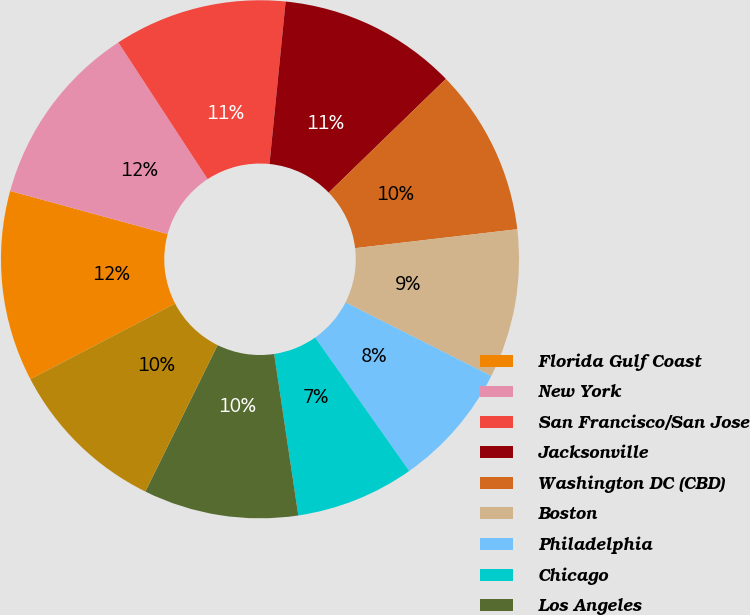Convert chart. <chart><loc_0><loc_0><loc_500><loc_500><pie_chart><fcel>Florida Gulf Coast<fcel>New York<fcel>San Francisco/San Jose<fcel>Jacksonville<fcel>Washington DC (CBD)<fcel>Boston<fcel>Philadelphia<fcel>Chicago<fcel>Los Angeles<fcel>Seattle<nl><fcel>11.91%<fcel>11.54%<fcel>10.79%<fcel>11.16%<fcel>10.41%<fcel>9.29%<fcel>7.79%<fcel>7.41%<fcel>9.66%<fcel>10.04%<nl></chart> 